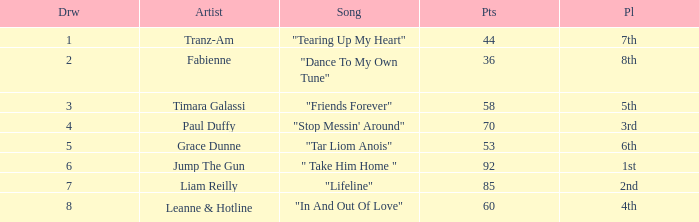What's the average draw for the song "stop messin' around"? 4.0. Give me the full table as a dictionary. {'header': ['Drw', 'Artist', 'Song', 'Pts', 'Pl'], 'rows': [['1', 'Tranz-Am', '"Tearing Up My Heart"', '44', '7th'], ['2', 'Fabienne', '"Dance To My Own Tune"', '36', '8th'], ['3', 'Timara Galassi', '"Friends Forever"', '58', '5th'], ['4', 'Paul Duffy', '"Stop Messin\' Around"', '70', '3rd'], ['5', 'Grace Dunne', '"Tar Liom Anois"', '53', '6th'], ['6', 'Jump The Gun', '" Take Him Home "', '92', '1st'], ['7', 'Liam Reilly', '"Lifeline"', '85', '2nd'], ['8', 'Leanne & Hotline', '"In And Out Of Love"', '60', '4th']]} 